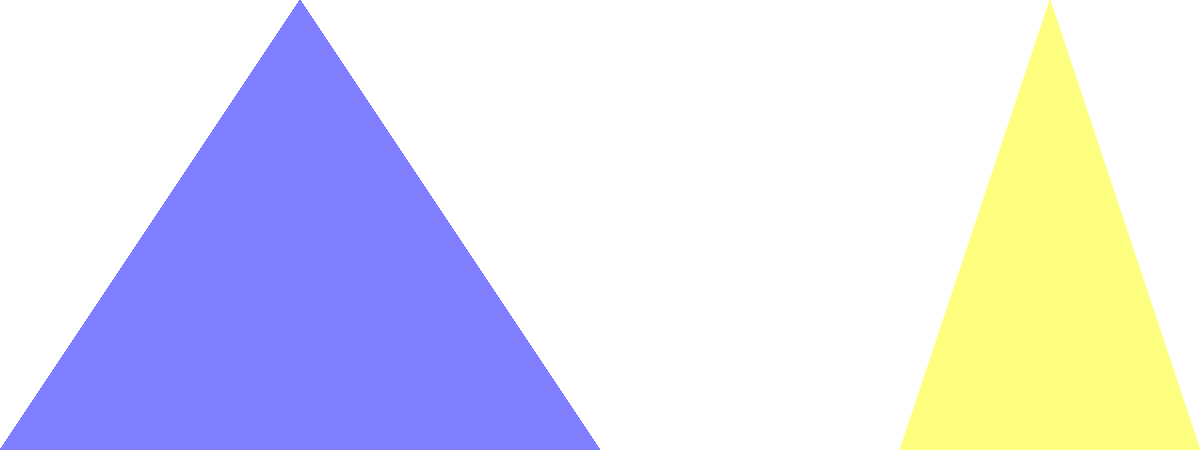In a cultural similarity study, two equilateral triangles represent Korean and American cultures in a Venn diagram. Each triangle has a side length of 4 units. If the triangles overlap as shown, with their bases aligned and a 1-unit overlap, what is the area of the region representing shared cultural aspects? To solve this problem, we need to follow these steps:

1) First, calculate the height of an equilateral triangle with side length 4:
   $h = \sqrt{4^2 - 2^2} = \sqrt{16 - 4} = \sqrt{12} = 2\sqrt{3}$

2) The area of overlap is a smaller equilateral triangle. Its base is the overlap width, which is 1 unit.

3) To find the height of this smaller triangle, we can set up a proportion:
   $\frac{4}{2\sqrt{3}} = \frac{1}{x}$, where $x$ is the height of the smaller triangle

4) Solve for $x$:
   $x = \frac{2\sqrt{3}}{4} = \frac{\sqrt{3}}{2}$

5) Now we can calculate the area of the overlap triangle:
   $A = \frac{1}{2} \times base \times height = \frac{1}{2} \times 1 \times \frac{\sqrt{3}}{2}$

6) Simplify:
   $A = \frac{\sqrt{3}}{4}$ square units

This area represents the shared cultural aspects between Korean and American cultures in the study.
Answer: $\frac{\sqrt{3}}{4}$ square units 